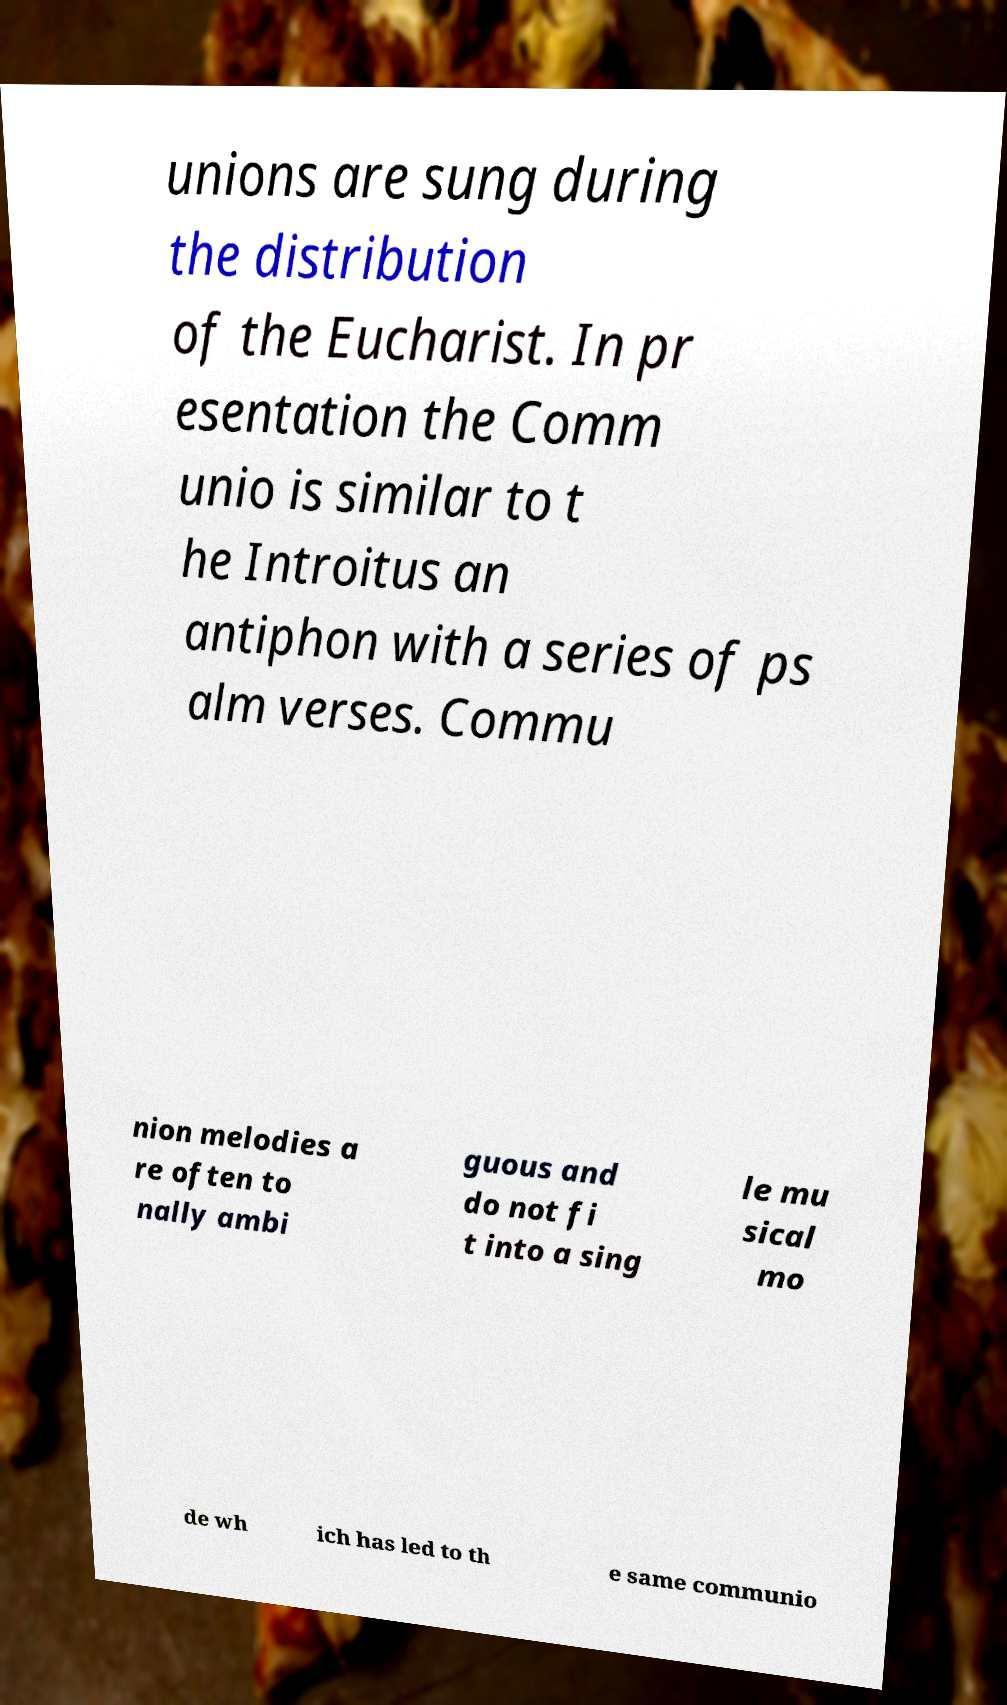Can you read and provide the text displayed in the image?This photo seems to have some interesting text. Can you extract and type it out for me? unions are sung during the distribution of the Eucharist. In pr esentation the Comm unio is similar to t he Introitus an antiphon with a series of ps alm verses. Commu nion melodies a re often to nally ambi guous and do not fi t into a sing le mu sical mo de wh ich has led to th e same communio 